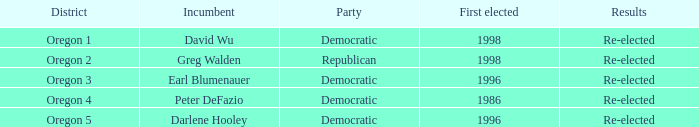Which democratic incumbent was originally elected in 1998? David Wu. 